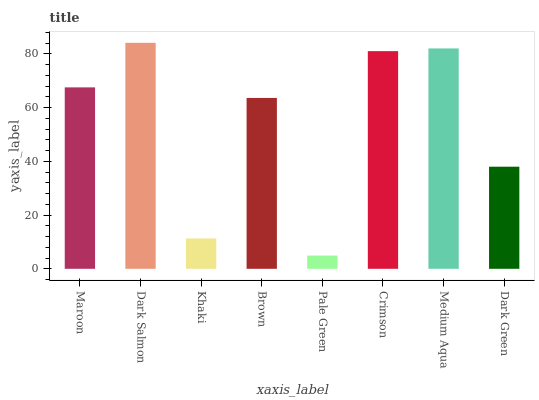Is Khaki the minimum?
Answer yes or no. No. Is Khaki the maximum?
Answer yes or no. No. Is Dark Salmon greater than Khaki?
Answer yes or no. Yes. Is Khaki less than Dark Salmon?
Answer yes or no. Yes. Is Khaki greater than Dark Salmon?
Answer yes or no. No. Is Dark Salmon less than Khaki?
Answer yes or no. No. Is Maroon the high median?
Answer yes or no. Yes. Is Brown the low median?
Answer yes or no. Yes. Is Dark Salmon the high median?
Answer yes or no. No. Is Medium Aqua the low median?
Answer yes or no. No. 